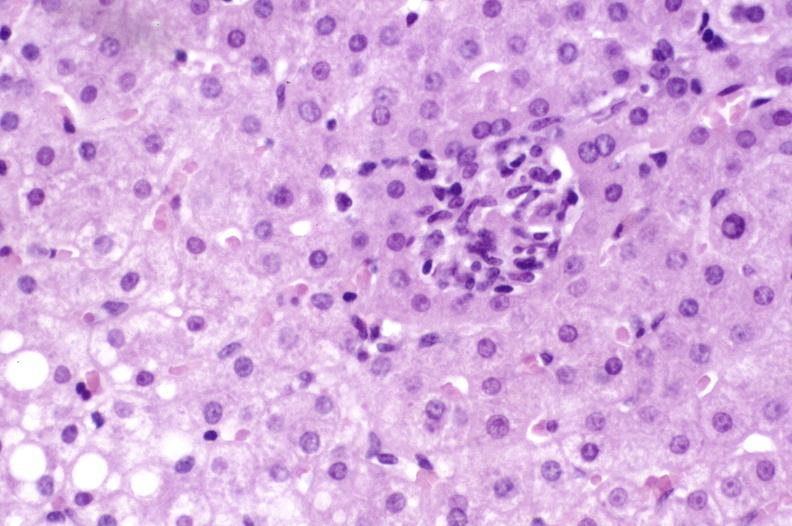does this image show primary biliary cirrhosis?
Answer the question using a single word or phrase. Yes 